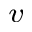Convert formula to latex. <formula><loc_0><loc_0><loc_500><loc_500>^ { v }</formula> 